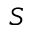<formula> <loc_0><loc_0><loc_500><loc_500>S</formula> 